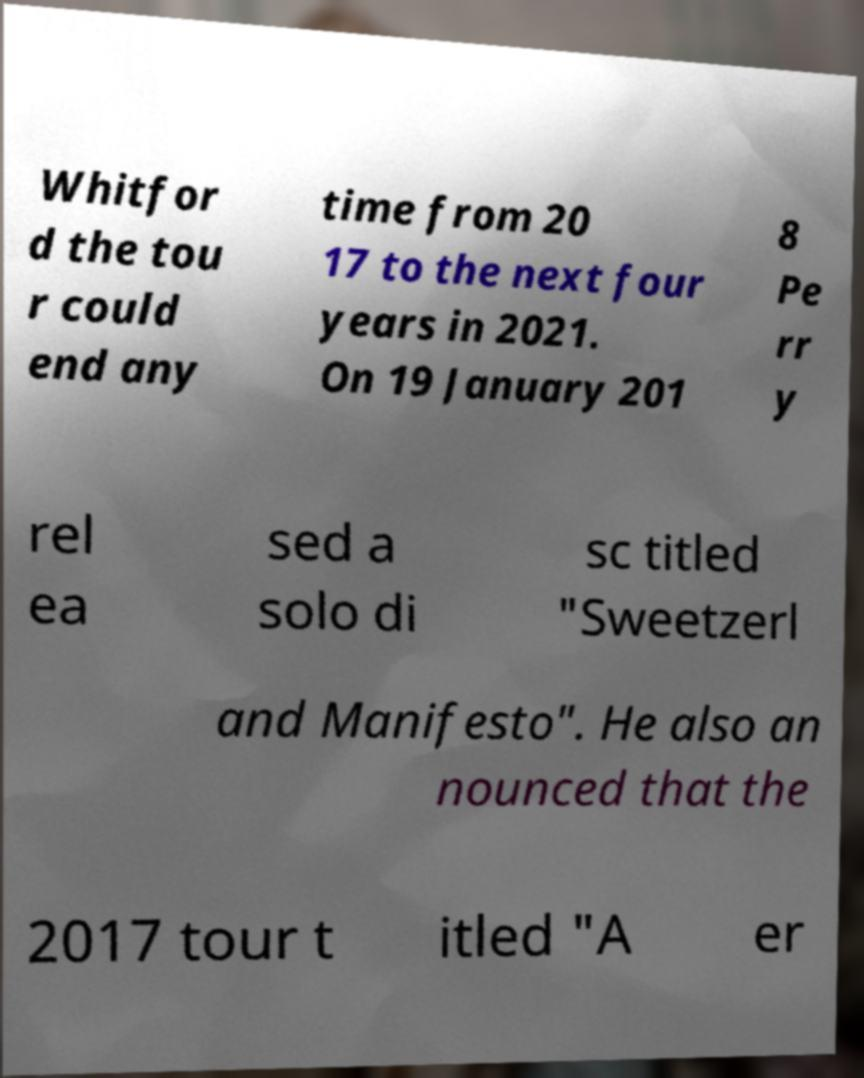There's text embedded in this image that I need extracted. Can you transcribe it verbatim? Whitfor d the tou r could end any time from 20 17 to the next four years in 2021. On 19 January 201 8 Pe rr y rel ea sed a solo di sc titled "Sweetzerl and Manifesto". He also an nounced that the 2017 tour t itled "A er 